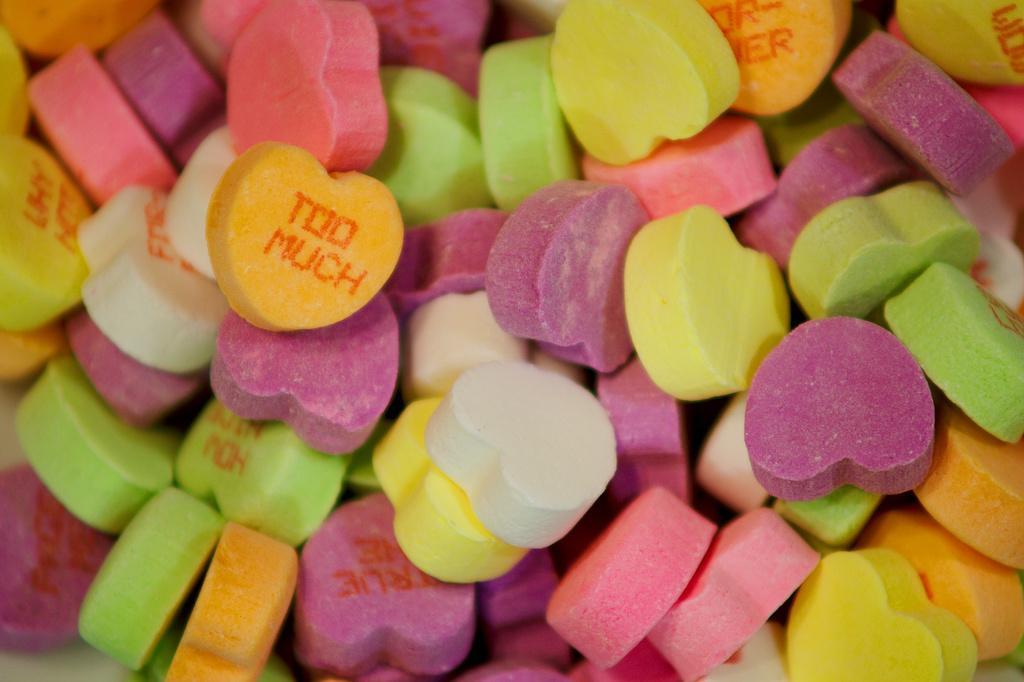Please provide a concise description of this image. In this image we can see colorful candies. These candies are in a heart shape. 